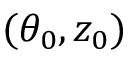<formula> <loc_0><loc_0><loc_500><loc_500>( \theta _ { 0 } , z _ { 0 } )</formula> 